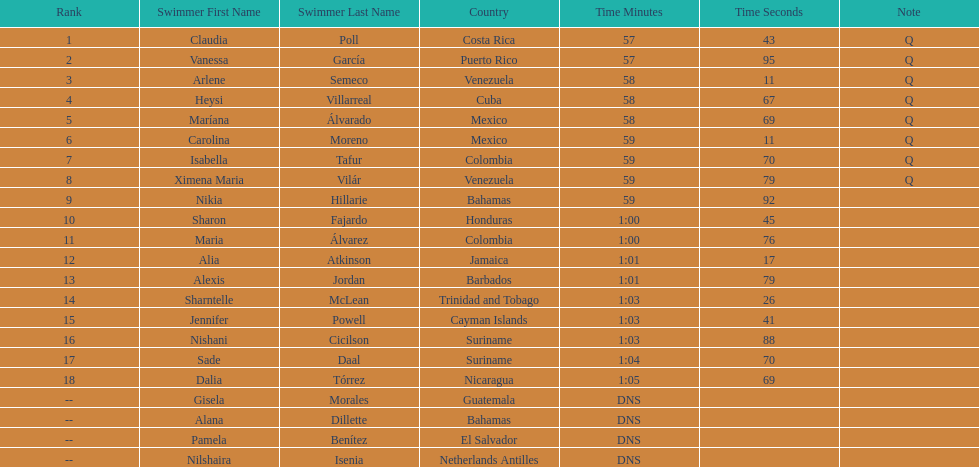How many swimmers had a time of at least 1:00 9. 